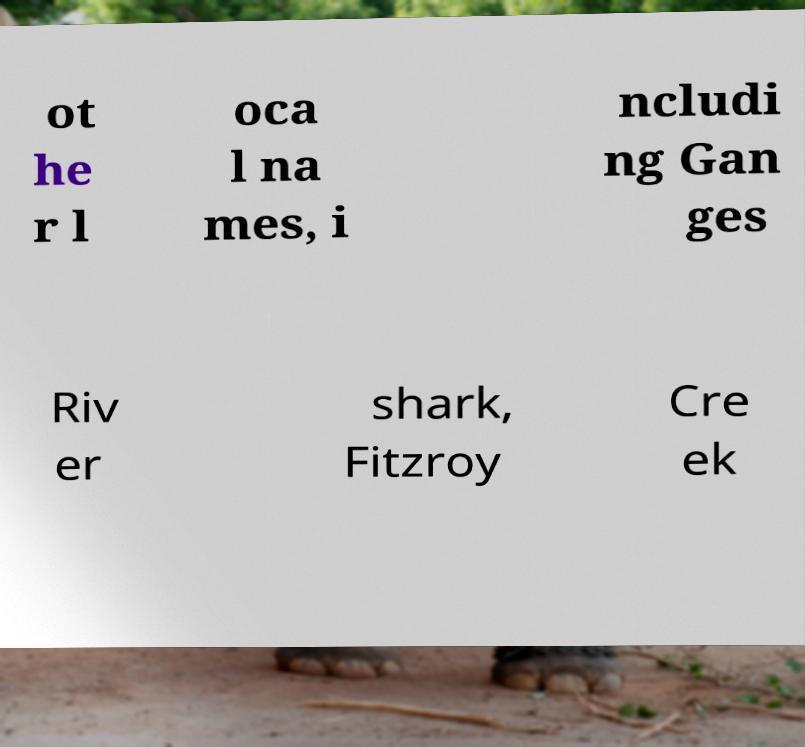Please identify and transcribe the text found in this image. ot he r l oca l na mes, i ncludi ng Gan ges Riv er shark, Fitzroy Cre ek 